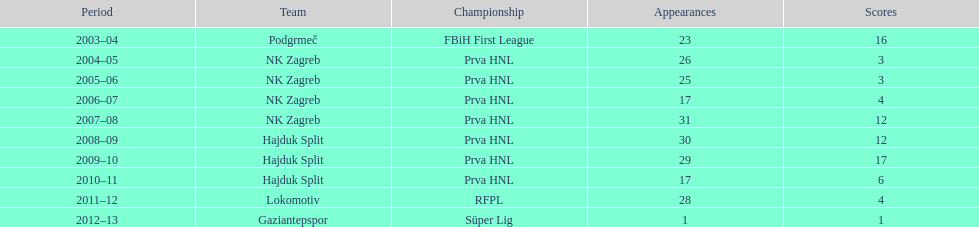At most 26 apps, how many goals were scored in 2004-2005 3. 